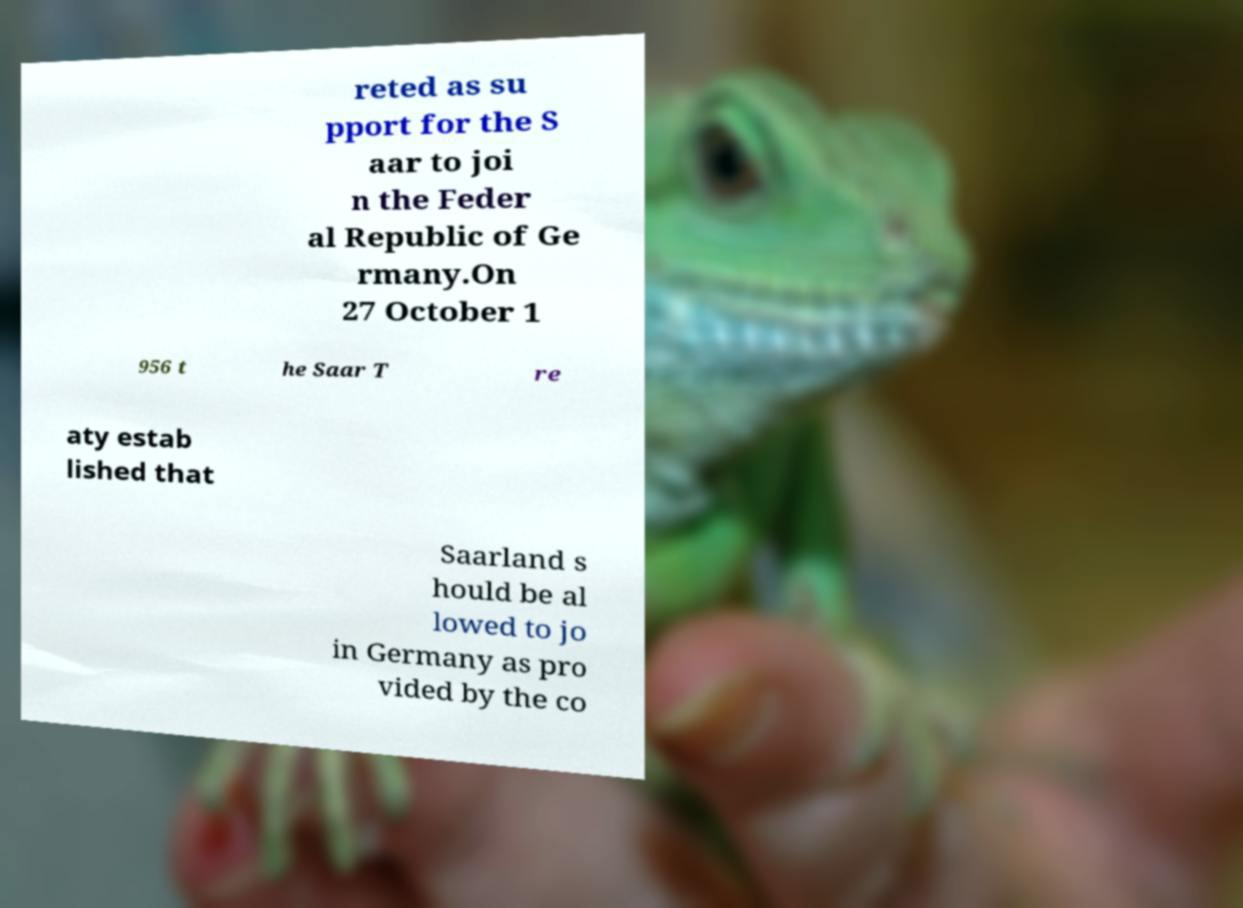What messages or text are displayed in this image? I need them in a readable, typed format. reted as su pport for the S aar to joi n the Feder al Republic of Ge rmany.On 27 October 1 956 t he Saar T re aty estab lished that Saarland s hould be al lowed to jo in Germany as pro vided by the co 